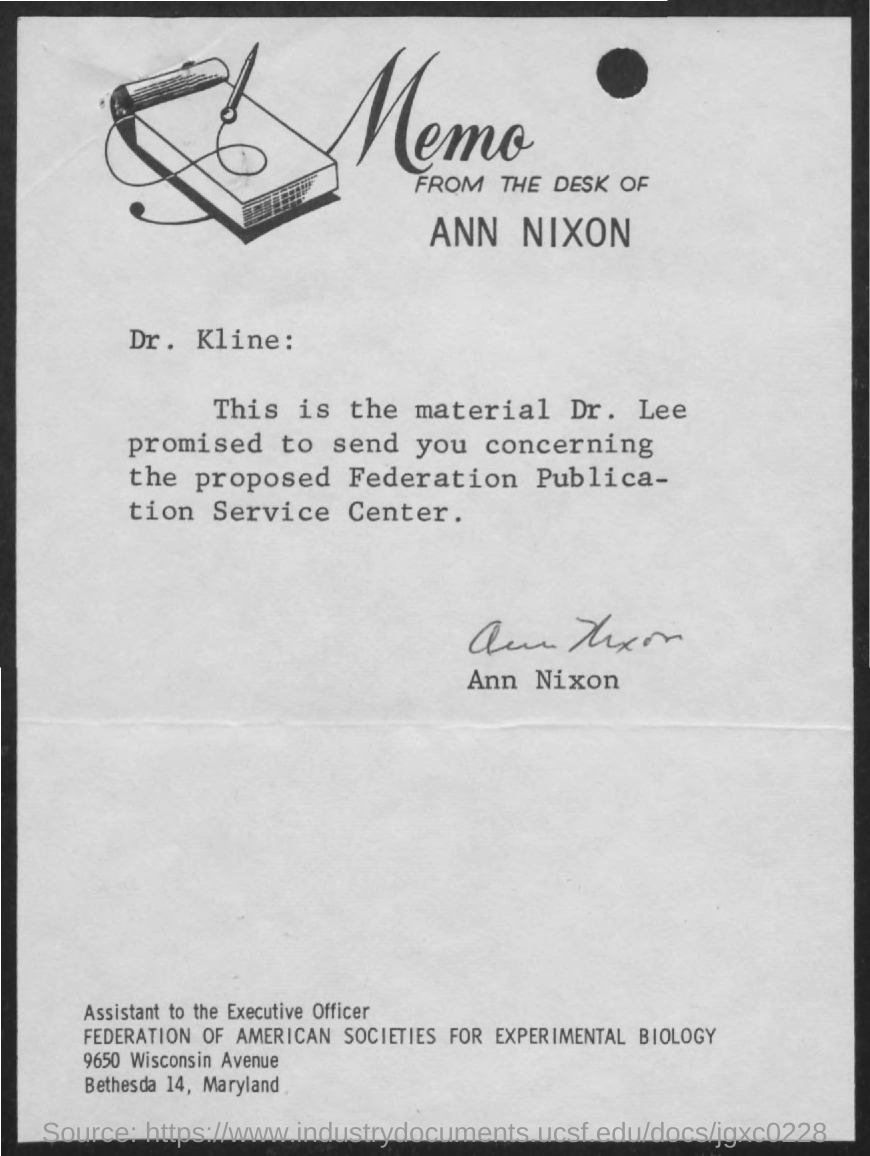Draw attention to some important aspects in this diagram. The sender of the memo is ANN NIXON. The memo is addressed to Dr. KLINE. Ann Nixon, the designation of the person in question, has been requested to report to the executive officer immediately. 